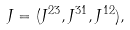Convert formula to latex. <formula><loc_0><loc_0><loc_500><loc_500>J = ( J ^ { 2 3 } , J ^ { 3 1 } , J ^ { 1 2 } ) ,</formula> 